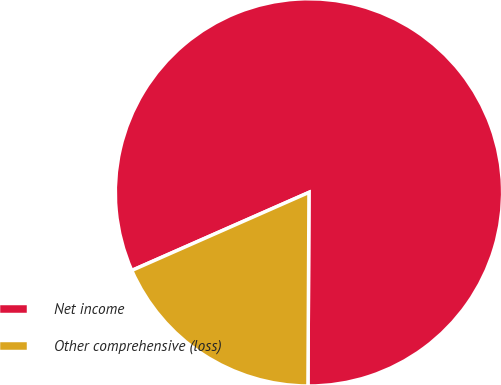Convert chart. <chart><loc_0><loc_0><loc_500><loc_500><pie_chart><fcel>Net income<fcel>Other comprehensive (loss)<nl><fcel>81.69%<fcel>18.31%<nl></chart> 